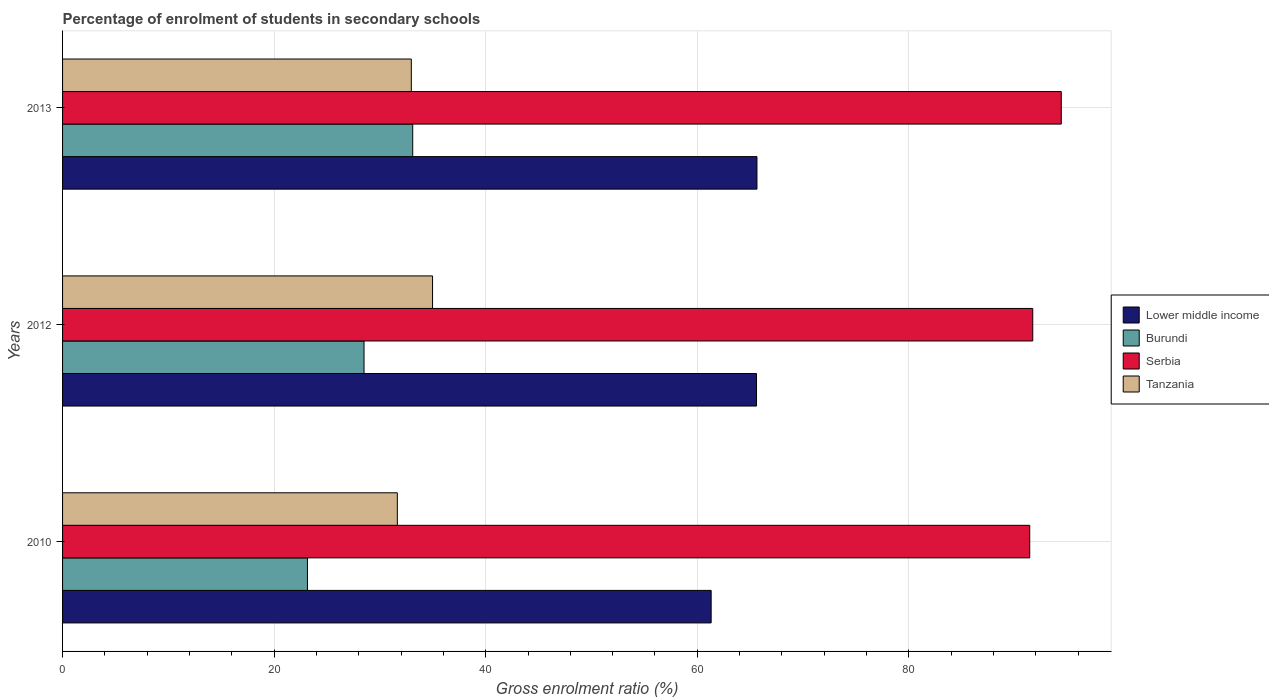How many different coloured bars are there?
Your answer should be compact. 4. Are the number of bars on each tick of the Y-axis equal?
Keep it short and to the point. Yes. How many bars are there on the 1st tick from the top?
Your response must be concise. 4. In how many cases, is the number of bars for a given year not equal to the number of legend labels?
Your answer should be compact. 0. What is the percentage of students enrolled in secondary schools in Serbia in 2013?
Offer a very short reply. 94.41. Across all years, what is the maximum percentage of students enrolled in secondary schools in Lower middle income?
Ensure brevity in your answer.  65.64. Across all years, what is the minimum percentage of students enrolled in secondary schools in Serbia?
Keep it short and to the point. 91.43. In which year was the percentage of students enrolled in secondary schools in Burundi maximum?
Your answer should be very brief. 2013. In which year was the percentage of students enrolled in secondary schools in Burundi minimum?
Offer a very short reply. 2010. What is the total percentage of students enrolled in secondary schools in Lower middle income in the graph?
Ensure brevity in your answer.  192.55. What is the difference between the percentage of students enrolled in secondary schools in Burundi in 2010 and that in 2012?
Offer a terse response. -5.35. What is the difference between the percentage of students enrolled in secondary schools in Lower middle income in 2010 and the percentage of students enrolled in secondary schools in Serbia in 2012?
Keep it short and to the point. -30.4. What is the average percentage of students enrolled in secondary schools in Tanzania per year?
Provide a short and direct response. 33.2. In the year 2010, what is the difference between the percentage of students enrolled in secondary schools in Lower middle income and percentage of students enrolled in secondary schools in Serbia?
Make the answer very short. -30.12. In how many years, is the percentage of students enrolled in secondary schools in Tanzania greater than 68 %?
Make the answer very short. 0. What is the ratio of the percentage of students enrolled in secondary schools in Serbia in 2012 to that in 2013?
Your response must be concise. 0.97. Is the percentage of students enrolled in secondary schools in Serbia in 2010 less than that in 2013?
Your answer should be very brief. Yes. What is the difference between the highest and the second highest percentage of students enrolled in secondary schools in Serbia?
Keep it short and to the point. 2.7. What is the difference between the highest and the lowest percentage of students enrolled in secondary schools in Burundi?
Your response must be concise. 9.95. In how many years, is the percentage of students enrolled in secondary schools in Tanzania greater than the average percentage of students enrolled in secondary schools in Tanzania taken over all years?
Your answer should be compact. 1. Is the sum of the percentage of students enrolled in secondary schools in Tanzania in 2010 and 2012 greater than the maximum percentage of students enrolled in secondary schools in Burundi across all years?
Keep it short and to the point. Yes. Is it the case that in every year, the sum of the percentage of students enrolled in secondary schools in Serbia and percentage of students enrolled in secondary schools in Burundi is greater than the sum of percentage of students enrolled in secondary schools in Lower middle income and percentage of students enrolled in secondary schools in Tanzania?
Provide a succinct answer. No. What does the 1st bar from the top in 2012 represents?
Give a very brief answer. Tanzania. What does the 3rd bar from the bottom in 2012 represents?
Ensure brevity in your answer.  Serbia. Are the values on the major ticks of X-axis written in scientific E-notation?
Make the answer very short. No. Where does the legend appear in the graph?
Provide a short and direct response. Center right. What is the title of the graph?
Offer a terse response. Percentage of enrolment of students in secondary schools. What is the label or title of the X-axis?
Your response must be concise. Gross enrolment ratio (%). What is the Gross enrolment ratio (%) in Lower middle income in 2010?
Your answer should be very brief. 61.31. What is the Gross enrolment ratio (%) of Burundi in 2010?
Your answer should be very brief. 23.15. What is the Gross enrolment ratio (%) in Serbia in 2010?
Give a very brief answer. 91.43. What is the Gross enrolment ratio (%) in Tanzania in 2010?
Keep it short and to the point. 31.65. What is the Gross enrolment ratio (%) of Lower middle income in 2012?
Keep it short and to the point. 65.6. What is the Gross enrolment ratio (%) in Burundi in 2012?
Your answer should be very brief. 28.5. What is the Gross enrolment ratio (%) in Serbia in 2012?
Make the answer very short. 91.71. What is the Gross enrolment ratio (%) in Tanzania in 2012?
Ensure brevity in your answer.  34.97. What is the Gross enrolment ratio (%) of Lower middle income in 2013?
Your answer should be very brief. 65.64. What is the Gross enrolment ratio (%) in Burundi in 2013?
Make the answer very short. 33.1. What is the Gross enrolment ratio (%) in Serbia in 2013?
Your answer should be very brief. 94.41. What is the Gross enrolment ratio (%) of Tanzania in 2013?
Ensure brevity in your answer.  32.97. Across all years, what is the maximum Gross enrolment ratio (%) of Lower middle income?
Offer a terse response. 65.64. Across all years, what is the maximum Gross enrolment ratio (%) in Burundi?
Your response must be concise. 33.1. Across all years, what is the maximum Gross enrolment ratio (%) of Serbia?
Your answer should be very brief. 94.41. Across all years, what is the maximum Gross enrolment ratio (%) in Tanzania?
Your answer should be compact. 34.97. Across all years, what is the minimum Gross enrolment ratio (%) of Lower middle income?
Your response must be concise. 61.31. Across all years, what is the minimum Gross enrolment ratio (%) of Burundi?
Keep it short and to the point. 23.15. Across all years, what is the minimum Gross enrolment ratio (%) of Serbia?
Give a very brief answer. 91.43. Across all years, what is the minimum Gross enrolment ratio (%) of Tanzania?
Offer a terse response. 31.65. What is the total Gross enrolment ratio (%) in Lower middle income in the graph?
Provide a short and direct response. 192.55. What is the total Gross enrolment ratio (%) of Burundi in the graph?
Keep it short and to the point. 84.75. What is the total Gross enrolment ratio (%) of Serbia in the graph?
Make the answer very short. 277.55. What is the total Gross enrolment ratio (%) of Tanzania in the graph?
Give a very brief answer. 99.59. What is the difference between the Gross enrolment ratio (%) of Lower middle income in 2010 and that in 2012?
Your answer should be compact. -4.29. What is the difference between the Gross enrolment ratio (%) in Burundi in 2010 and that in 2012?
Your answer should be compact. -5.35. What is the difference between the Gross enrolment ratio (%) of Serbia in 2010 and that in 2012?
Your response must be concise. -0.28. What is the difference between the Gross enrolment ratio (%) in Tanzania in 2010 and that in 2012?
Provide a succinct answer. -3.33. What is the difference between the Gross enrolment ratio (%) of Lower middle income in 2010 and that in 2013?
Offer a very short reply. -4.33. What is the difference between the Gross enrolment ratio (%) in Burundi in 2010 and that in 2013?
Ensure brevity in your answer.  -9.95. What is the difference between the Gross enrolment ratio (%) of Serbia in 2010 and that in 2013?
Offer a terse response. -2.98. What is the difference between the Gross enrolment ratio (%) in Tanzania in 2010 and that in 2013?
Your answer should be compact. -1.32. What is the difference between the Gross enrolment ratio (%) in Lower middle income in 2012 and that in 2013?
Make the answer very short. -0.04. What is the difference between the Gross enrolment ratio (%) of Burundi in 2012 and that in 2013?
Your answer should be very brief. -4.6. What is the difference between the Gross enrolment ratio (%) of Serbia in 2012 and that in 2013?
Your answer should be very brief. -2.7. What is the difference between the Gross enrolment ratio (%) in Tanzania in 2012 and that in 2013?
Keep it short and to the point. 2.01. What is the difference between the Gross enrolment ratio (%) of Lower middle income in 2010 and the Gross enrolment ratio (%) of Burundi in 2012?
Make the answer very short. 32.81. What is the difference between the Gross enrolment ratio (%) of Lower middle income in 2010 and the Gross enrolment ratio (%) of Serbia in 2012?
Provide a short and direct response. -30.4. What is the difference between the Gross enrolment ratio (%) of Lower middle income in 2010 and the Gross enrolment ratio (%) of Tanzania in 2012?
Keep it short and to the point. 26.34. What is the difference between the Gross enrolment ratio (%) in Burundi in 2010 and the Gross enrolment ratio (%) in Serbia in 2012?
Make the answer very short. -68.56. What is the difference between the Gross enrolment ratio (%) in Burundi in 2010 and the Gross enrolment ratio (%) in Tanzania in 2012?
Give a very brief answer. -11.83. What is the difference between the Gross enrolment ratio (%) of Serbia in 2010 and the Gross enrolment ratio (%) of Tanzania in 2012?
Your response must be concise. 56.45. What is the difference between the Gross enrolment ratio (%) of Lower middle income in 2010 and the Gross enrolment ratio (%) of Burundi in 2013?
Ensure brevity in your answer.  28.21. What is the difference between the Gross enrolment ratio (%) of Lower middle income in 2010 and the Gross enrolment ratio (%) of Serbia in 2013?
Offer a terse response. -33.1. What is the difference between the Gross enrolment ratio (%) in Lower middle income in 2010 and the Gross enrolment ratio (%) in Tanzania in 2013?
Your answer should be very brief. 28.34. What is the difference between the Gross enrolment ratio (%) in Burundi in 2010 and the Gross enrolment ratio (%) in Serbia in 2013?
Provide a succinct answer. -71.26. What is the difference between the Gross enrolment ratio (%) of Burundi in 2010 and the Gross enrolment ratio (%) of Tanzania in 2013?
Your response must be concise. -9.82. What is the difference between the Gross enrolment ratio (%) in Serbia in 2010 and the Gross enrolment ratio (%) in Tanzania in 2013?
Keep it short and to the point. 58.46. What is the difference between the Gross enrolment ratio (%) of Lower middle income in 2012 and the Gross enrolment ratio (%) of Burundi in 2013?
Make the answer very short. 32.5. What is the difference between the Gross enrolment ratio (%) in Lower middle income in 2012 and the Gross enrolment ratio (%) in Serbia in 2013?
Your answer should be very brief. -28.81. What is the difference between the Gross enrolment ratio (%) of Lower middle income in 2012 and the Gross enrolment ratio (%) of Tanzania in 2013?
Your answer should be compact. 32.63. What is the difference between the Gross enrolment ratio (%) of Burundi in 2012 and the Gross enrolment ratio (%) of Serbia in 2013?
Offer a very short reply. -65.91. What is the difference between the Gross enrolment ratio (%) in Burundi in 2012 and the Gross enrolment ratio (%) in Tanzania in 2013?
Give a very brief answer. -4.47. What is the difference between the Gross enrolment ratio (%) of Serbia in 2012 and the Gross enrolment ratio (%) of Tanzania in 2013?
Ensure brevity in your answer.  58.74. What is the average Gross enrolment ratio (%) in Lower middle income per year?
Provide a short and direct response. 64.18. What is the average Gross enrolment ratio (%) in Burundi per year?
Keep it short and to the point. 28.25. What is the average Gross enrolment ratio (%) in Serbia per year?
Offer a very short reply. 92.52. What is the average Gross enrolment ratio (%) of Tanzania per year?
Give a very brief answer. 33.2. In the year 2010, what is the difference between the Gross enrolment ratio (%) of Lower middle income and Gross enrolment ratio (%) of Burundi?
Your response must be concise. 38.16. In the year 2010, what is the difference between the Gross enrolment ratio (%) of Lower middle income and Gross enrolment ratio (%) of Serbia?
Keep it short and to the point. -30.12. In the year 2010, what is the difference between the Gross enrolment ratio (%) in Lower middle income and Gross enrolment ratio (%) in Tanzania?
Your answer should be compact. 29.67. In the year 2010, what is the difference between the Gross enrolment ratio (%) in Burundi and Gross enrolment ratio (%) in Serbia?
Offer a very short reply. -68.28. In the year 2010, what is the difference between the Gross enrolment ratio (%) in Burundi and Gross enrolment ratio (%) in Tanzania?
Make the answer very short. -8.5. In the year 2010, what is the difference between the Gross enrolment ratio (%) of Serbia and Gross enrolment ratio (%) of Tanzania?
Your answer should be very brief. 59.78. In the year 2012, what is the difference between the Gross enrolment ratio (%) in Lower middle income and Gross enrolment ratio (%) in Burundi?
Make the answer very short. 37.1. In the year 2012, what is the difference between the Gross enrolment ratio (%) of Lower middle income and Gross enrolment ratio (%) of Serbia?
Your response must be concise. -26.11. In the year 2012, what is the difference between the Gross enrolment ratio (%) of Lower middle income and Gross enrolment ratio (%) of Tanzania?
Make the answer very short. 30.63. In the year 2012, what is the difference between the Gross enrolment ratio (%) in Burundi and Gross enrolment ratio (%) in Serbia?
Your answer should be very brief. -63.21. In the year 2012, what is the difference between the Gross enrolment ratio (%) of Burundi and Gross enrolment ratio (%) of Tanzania?
Give a very brief answer. -6.48. In the year 2012, what is the difference between the Gross enrolment ratio (%) of Serbia and Gross enrolment ratio (%) of Tanzania?
Provide a succinct answer. 56.74. In the year 2013, what is the difference between the Gross enrolment ratio (%) of Lower middle income and Gross enrolment ratio (%) of Burundi?
Provide a succinct answer. 32.54. In the year 2013, what is the difference between the Gross enrolment ratio (%) of Lower middle income and Gross enrolment ratio (%) of Serbia?
Your answer should be compact. -28.77. In the year 2013, what is the difference between the Gross enrolment ratio (%) in Lower middle income and Gross enrolment ratio (%) in Tanzania?
Ensure brevity in your answer.  32.68. In the year 2013, what is the difference between the Gross enrolment ratio (%) in Burundi and Gross enrolment ratio (%) in Serbia?
Offer a terse response. -61.31. In the year 2013, what is the difference between the Gross enrolment ratio (%) of Burundi and Gross enrolment ratio (%) of Tanzania?
Offer a terse response. 0.13. In the year 2013, what is the difference between the Gross enrolment ratio (%) in Serbia and Gross enrolment ratio (%) in Tanzania?
Offer a very short reply. 61.44. What is the ratio of the Gross enrolment ratio (%) of Lower middle income in 2010 to that in 2012?
Offer a terse response. 0.93. What is the ratio of the Gross enrolment ratio (%) in Burundi in 2010 to that in 2012?
Keep it short and to the point. 0.81. What is the ratio of the Gross enrolment ratio (%) of Tanzania in 2010 to that in 2012?
Your answer should be compact. 0.9. What is the ratio of the Gross enrolment ratio (%) in Lower middle income in 2010 to that in 2013?
Provide a short and direct response. 0.93. What is the ratio of the Gross enrolment ratio (%) of Burundi in 2010 to that in 2013?
Your response must be concise. 0.7. What is the ratio of the Gross enrolment ratio (%) of Serbia in 2010 to that in 2013?
Your answer should be compact. 0.97. What is the ratio of the Gross enrolment ratio (%) in Tanzania in 2010 to that in 2013?
Provide a short and direct response. 0.96. What is the ratio of the Gross enrolment ratio (%) of Burundi in 2012 to that in 2013?
Make the answer very short. 0.86. What is the ratio of the Gross enrolment ratio (%) in Serbia in 2012 to that in 2013?
Keep it short and to the point. 0.97. What is the ratio of the Gross enrolment ratio (%) in Tanzania in 2012 to that in 2013?
Keep it short and to the point. 1.06. What is the difference between the highest and the second highest Gross enrolment ratio (%) in Lower middle income?
Make the answer very short. 0.04. What is the difference between the highest and the second highest Gross enrolment ratio (%) of Burundi?
Your answer should be very brief. 4.6. What is the difference between the highest and the second highest Gross enrolment ratio (%) of Serbia?
Keep it short and to the point. 2.7. What is the difference between the highest and the second highest Gross enrolment ratio (%) of Tanzania?
Offer a terse response. 2.01. What is the difference between the highest and the lowest Gross enrolment ratio (%) in Lower middle income?
Offer a very short reply. 4.33. What is the difference between the highest and the lowest Gross enrolment ratio (%) in Burundi?
Keep it short and to the point. 9.95. What is the difference between the highest and the lowest Gross enrolment ratio (%) in Serbia?
Offer a very short reply. 2.98. What is the difference between the highest and the lowest Gross enrolment ratio (%) in Tanzania?
Provide a short and direct response. 3.33. 